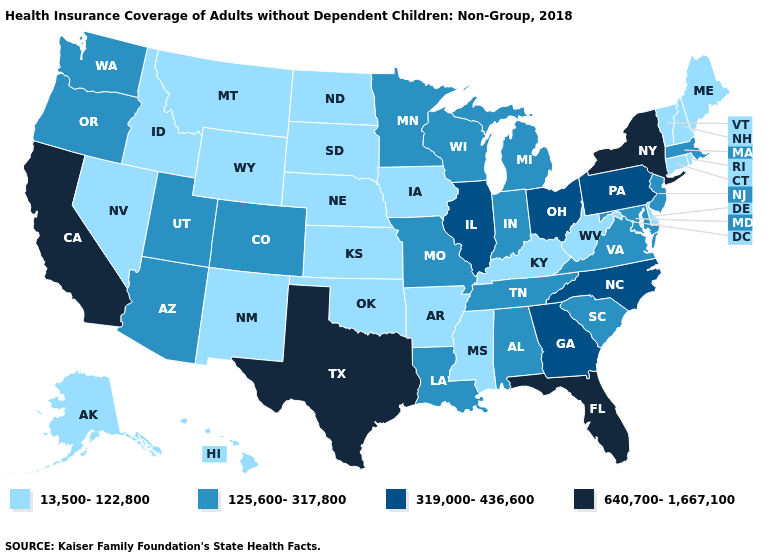What is the highest value in states that border Kansas?
Concise answer only. 125,600-317,800. What is the value of New Mexico?
Write a very short answer. 13,500-122,800. Does the map have missing data?
Give a very brief answer. No. What is the value of Tennessee?
Give a very brief answer. 125,600-317,800. What is the highest value in the MidWest ?
Concise answer only. 319,000-436,600. Which states hav the highest value in the South?
Give a very brief answer. Florida, Texas. Does Wisconsin have the highest value in the USA?
Write a very short answer. No. Does Minnesota have the highest value in the MidWest?
Quick response, please. No. Does Oregon have the lowest value in the West?
Write a very short answer. No. Name the states that have a value in the range 13,500-122,800?
Concise answer only. Alaska, Arkansas, Connecticut, Delaware, Hawaii, Idaho, Iowa, Kansas, Kentucky, Maine, Mississippi, Montana, Nebraska, Nevada, New Hampshire, New Mexico, North Dakota, Oklahoma, Rhode Island, South Dakota, Vermont, West Virginia, Wyoming. Does Illinois have the lowest value in the MidWest?
Write a very short answer. No. Which states have the lowest value in the South?
Answer briefly. Arkansas, Delaware, Kentucky, Mississippi, Oklahoma, West Virginia. What is the highest value in the Northeast ?
Quick response, please. 640,700-1,667,100. Name the states that have a value in the range 319,000-436,600?
Quick response, please. Georgia, Illinois, North Carolina, Ohio, Pennsylvania. 